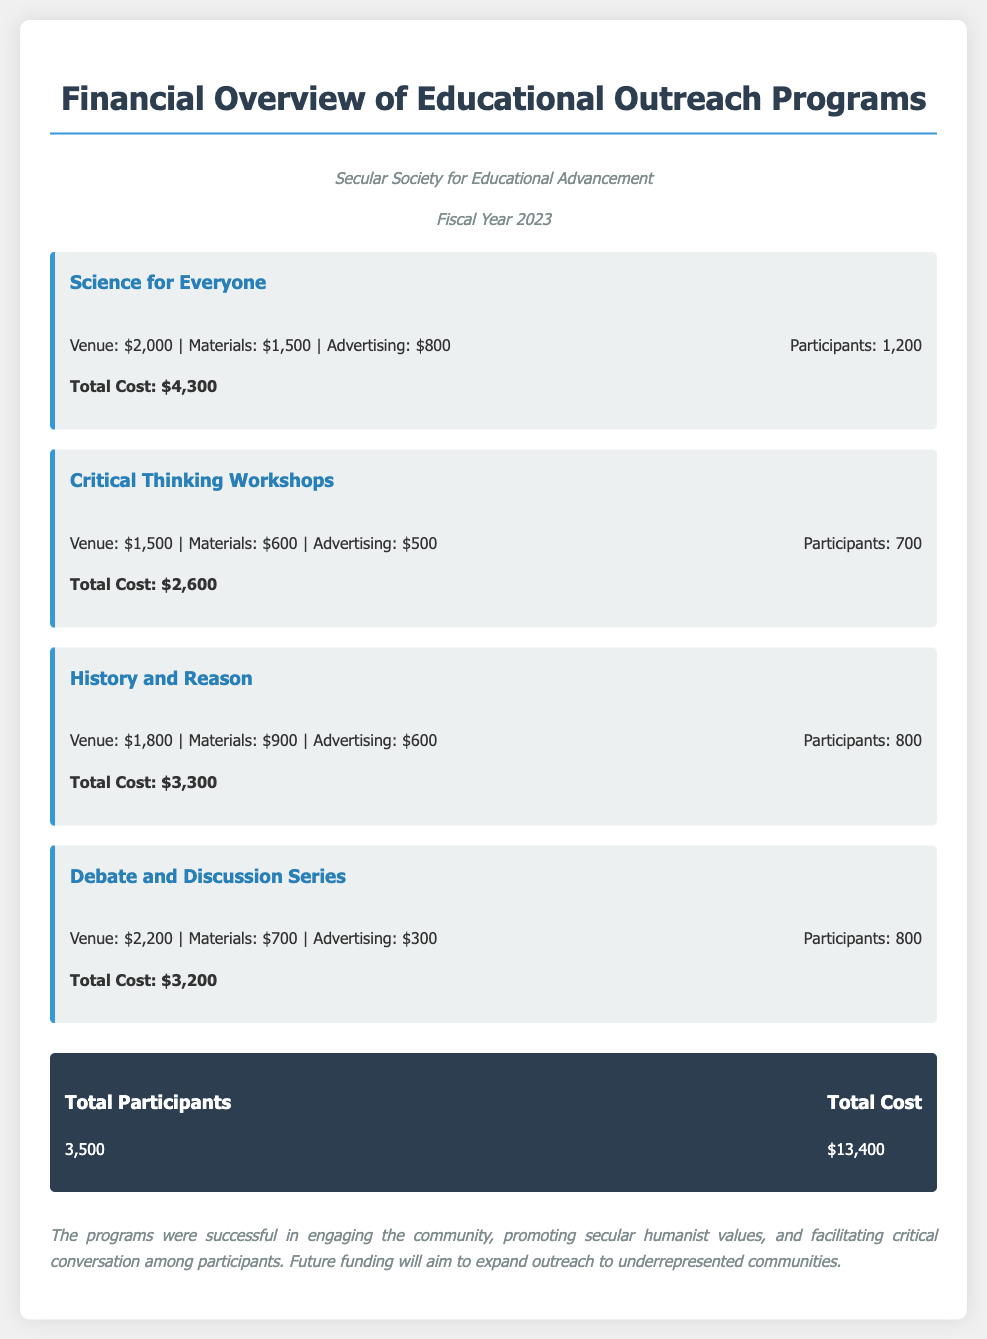What is the total cost of the "Science for Everyone" program? The total cost is specifically mentioned in the program details for "Science for Everyone" as $4,300.
Answer: $4,300 How many participants attended the "Critical Thinking Workshops"? The number of participants is listed in the program details for the "Critical Thinking Workshops" as 700.
Answer: 700 What is the total number of participants across all programs? The total number of participants is summarized in the total section as 3,500.
Answer: 3,500 What was the advertising cost for the "Debate and Discussion Series"? The advertising cost is detailed in the program information for "Debate and Discussion Series" as $300.
Answer: $300 What is the total cost incurred for all educational outreach programs? The total cost is summed up in the report as $13,400 for all outreach programs.
Answer: $13,400 Which program had the highest number of participants? By comparing participant numbers, "Science for Everyone" had the highest at 1,200 participants.
Answer: Science for Everyone What was the total venue cost for the "History and Reason" program? The venue cost is shown in the details for "History and Reason" as $1,800.
Answer: $1,800 What is mentioned as a goal for future funding? The report states that future funding will aim to expand outreach to underrepresented communities.
Answer: Expand outreach to underrepresented communities How much was spent on materials for the "Critical Thinking Workshops"? The materials cost for the "Critical Thinking Workshops" is stated as $600 in the financial details.
Answer: $600 